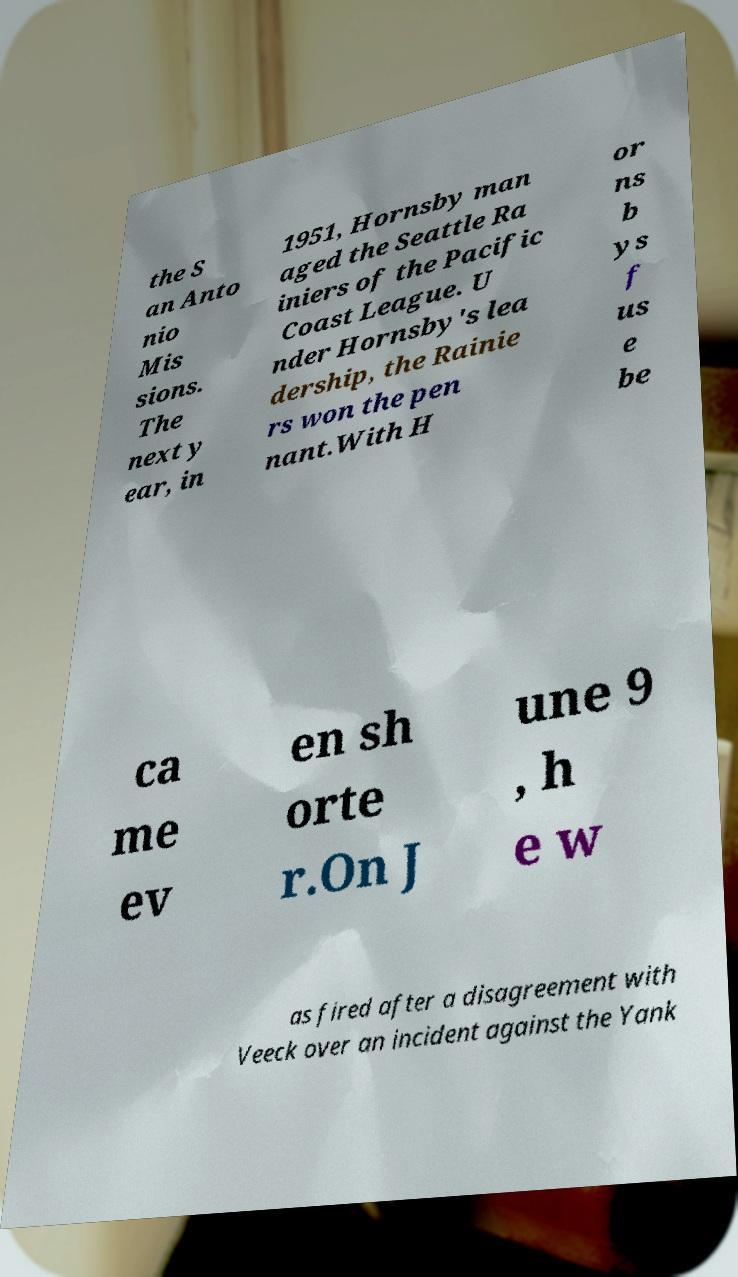I need the written content from this picture converted into text. Can you do that? the S an Anto nio Mis sions. The next y ear, in 1951, Hornsby man aged the Seattle Ra iniers of the Pacific Coast League. U nder Hornsby's lea dership, the Rainie rs won the pen nant.With H or ns b ys f us e be ca me ev en sh orte r.On J une 9 , h e w as fired after a disagreement with Veeck over an incident against the Yank 